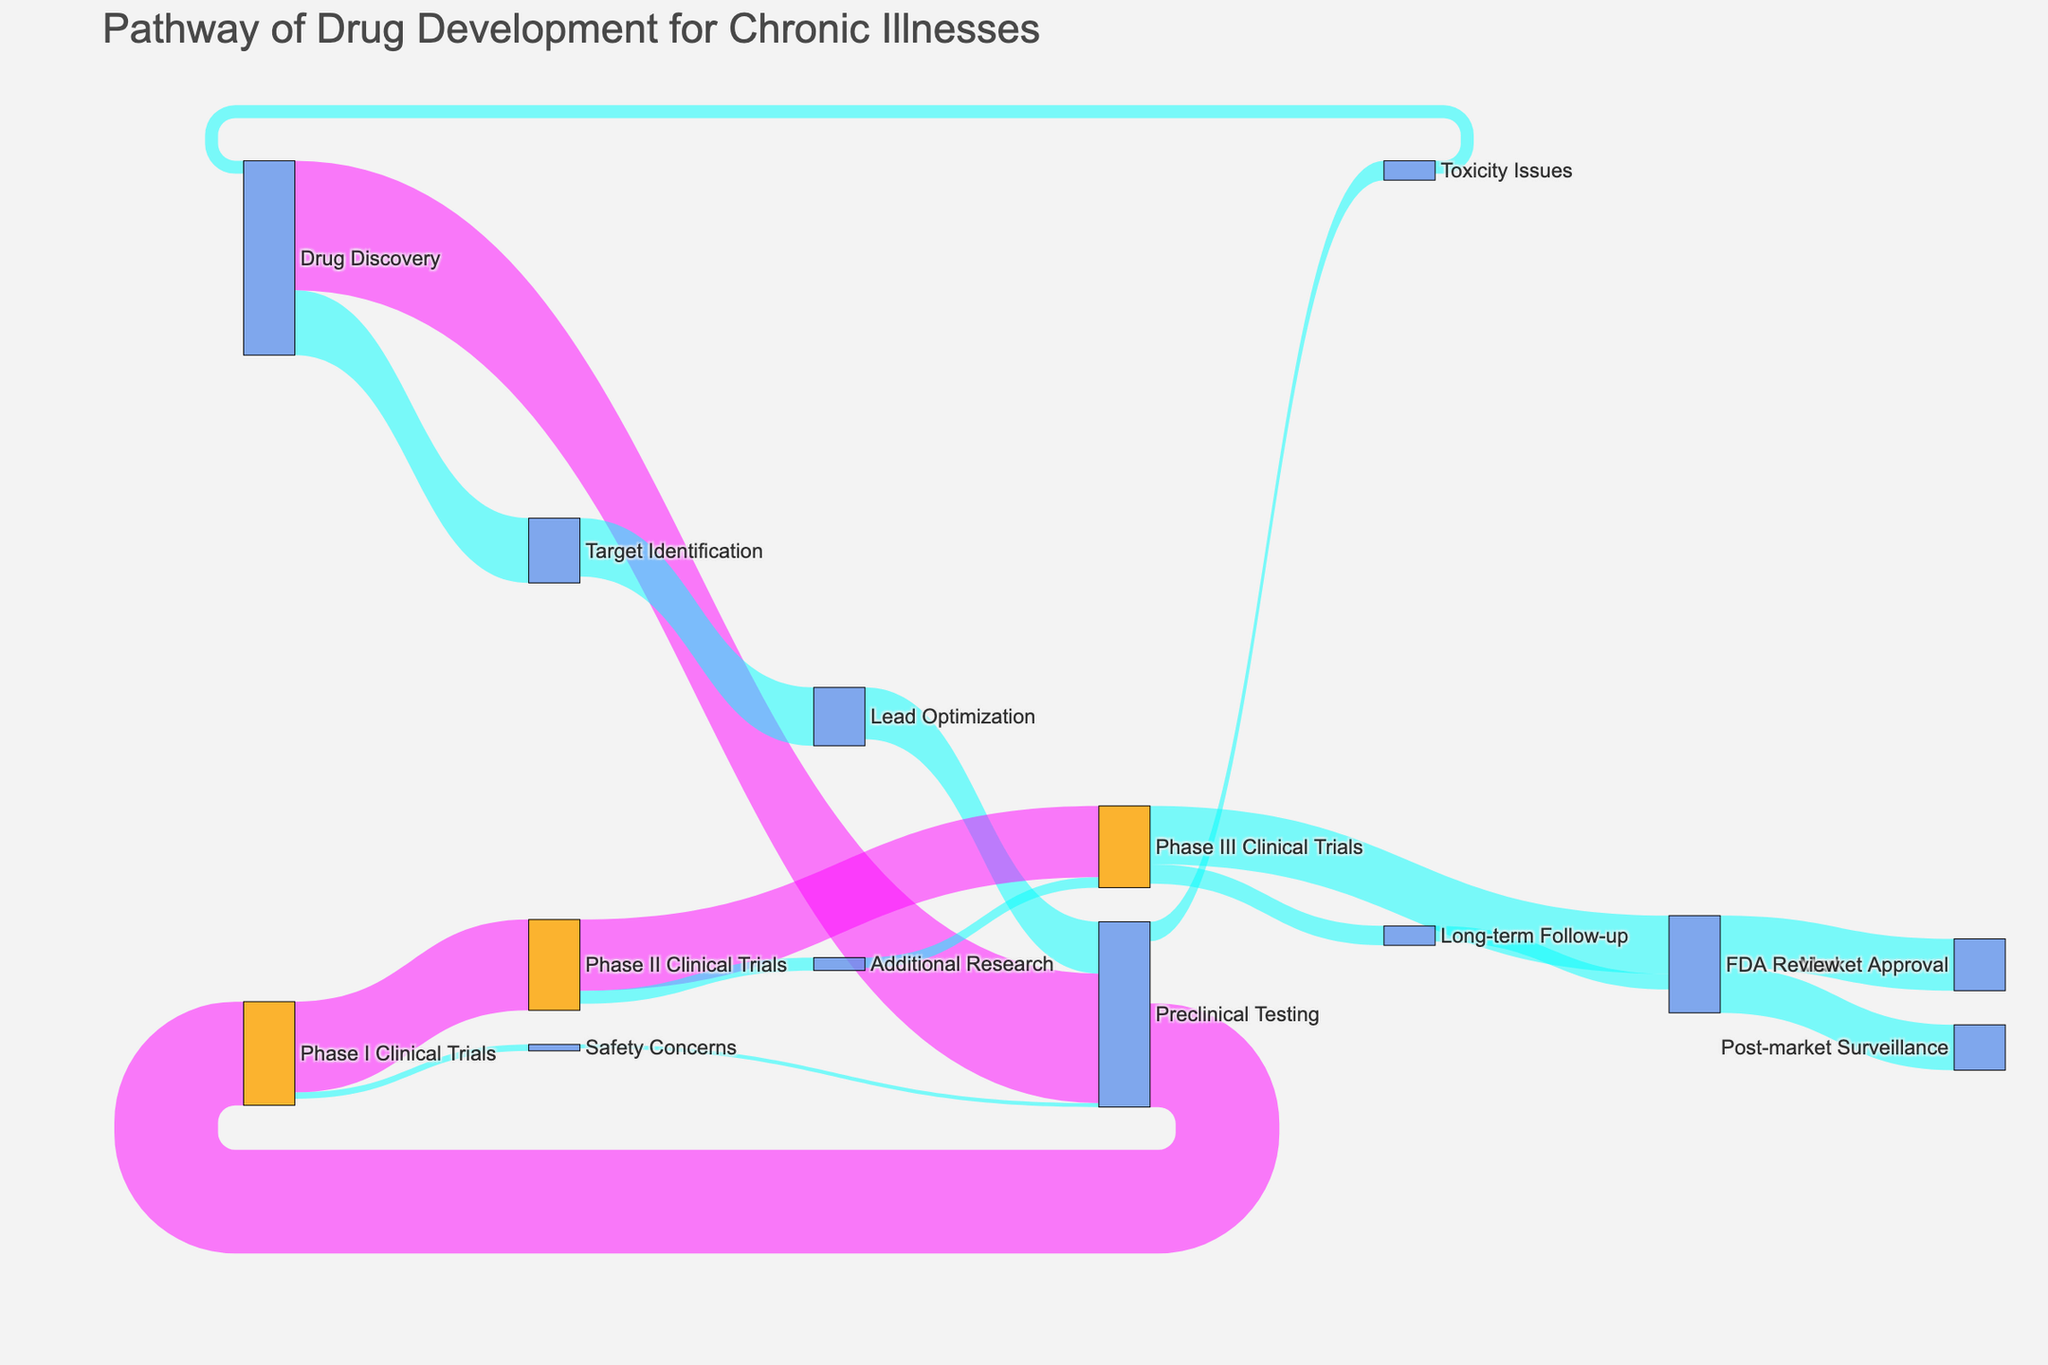What is the value of the flow from Preclinical Testing to Phase I Clinical Trials? The flow represents the transition and its strength from Preclinical Testing to Phase I Clinical Trials. According to the diagram, the value is shown directly.
Answer: 80 What is the total value of flows originating from FDA Review? The total value is the sum of the values of all flows that start from FDA Review, which are FDA Review to Market Approval, FDA Review to Post-market Surveillance. 40 + 35 = 75
Answer: 75 Which transition has the highest value and what is that value? To find the highest value, explore each flow’s value. The highest value among the transitions is Drug Discovery to Preclinical Testing.
Answer: 100 Is the flow value from Phase II Clinical Trials to Additional Research greater than the value from Additional Research to Phase III Clinical Trials? Check and compare the flow values. Phase II Clinical Trials to Additional Research is 10, which is greater than 8, the value from Additional Research to Phase III Clinical Trials.
Answer: Yes How many distinct stages are there in the drug development pathway shown? Count the unique labels in the nodes list. Each label represents a stage, and there are 16 unique stages.
Answer: 16 What stage follows Lead Optimization, and what is the value of that flow? Follow the arrows from Lead Optimization. The next stage is Preclinical Testing with a flow value of 40.
Answer: Preclinical Testing, 40 Calculate the sum of all values flowing into the Phase III Clinical Trials. Sum all incoming flows to Phase III Clinical Trials which are from Phase II Clinical Trials (55) and from Additional Research (8). 55 + 8 = 63
Answer: 63 What color represents transitions with a value greater than 50 in the diagram? By observing the color coding, transitions with a value greater than 50 are represented in magenta.
Answer: Magenta From which stages does the FDA Review receive flows, and what are their combined values? Identify all incoming flows to FDA Review: from Phase III Clinical Trials (45), Long-term Follow-up (12). Summing these gives 45 + 12 = 57.
Answer: Phase III Clinical Trials, Long-term Follow-up, combined value: 57 